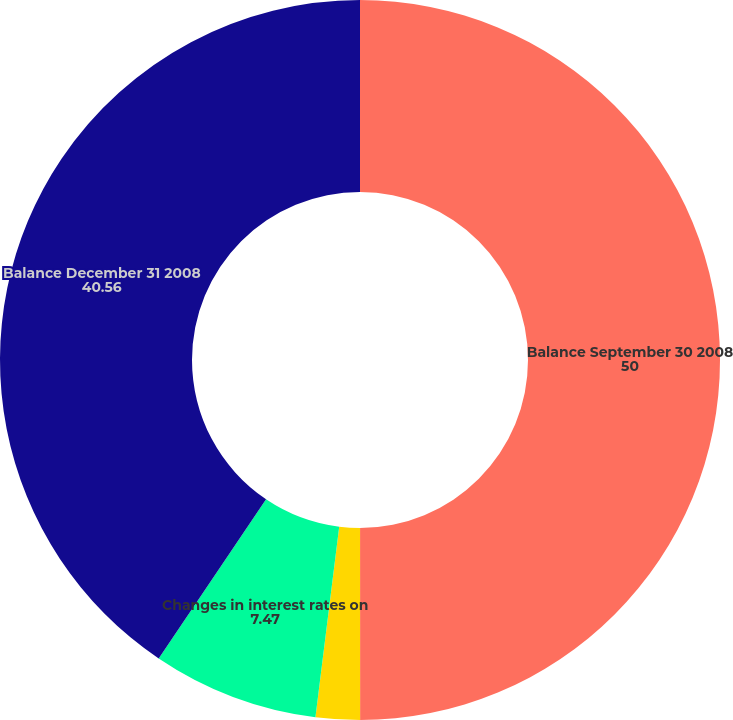Convert chart to OTSL. <chart><loc_0><loc_0><loc_500><loc_500><pie_chart><fcel>Balance September 30 2008<fcel>Accretion into interest income<fcel>Changes in interest rates on<fcel>Balance December 31 2008<nl><fcel>50.0%<fcel>1.98%<fcel>7.47%<fcel>40.56%<nl></chart> 